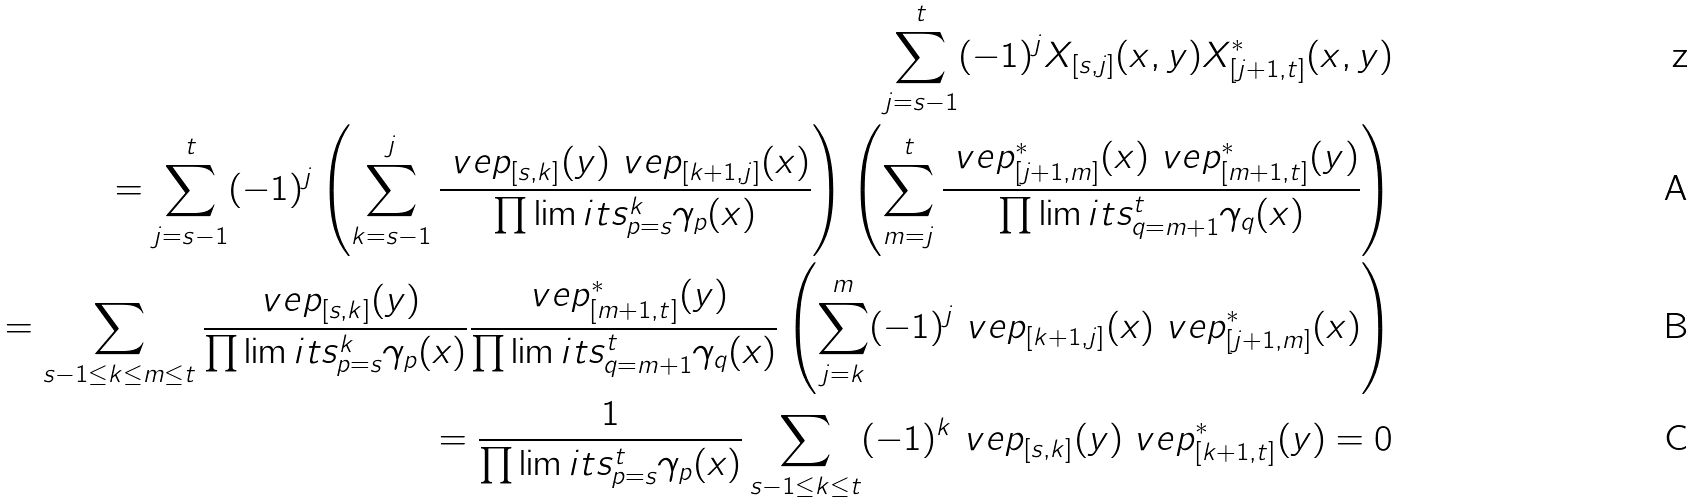Convert formula to latex. <formula><loc_0><loc_0><loc_500><loc_500>\sum _ { j = s - 1 } ^ { t } ( - 1 ) ^ { j } X _ { [ s , j ] } ( x , y ) X ^ { * } _ { [ j + 1 , t ] } ( x , y ) \\ = \sum _ { j = s - 1 } ^ { t } ( - 1 ) ^ { j } \left ( \sum _ { k = s - 1 } ^ { j } \frac { \ v e p _ { [ s , k ] } ( y ) \ v e p _ { [ k + 1 , j ] } ( x ) } { \prod \lim i t s _ { p = s } ^ { k } \gamma _ { p } ( x ) } \right ) \left ( \sum _ { m = j } ^ { t } \frac { \ v e p ^ { * } _ { [ j + 1 , m ] } ( x ) \ v e p ^ { * } _ { [ m + 1 , t ] } ( y ) } { \prod \lim i t s _ { q = m + 1 } ^ { t } \gamma _ { q } ( x ) } \right ) \\ = \sum _ { s - 1 \leq k \leq m \leq t } \frac { \ v e p _ { [ s , k ] } ( y ) } { \prod \lim i t s _ { p = s } ^ { k } \gamma _ { p } ( x ) } \frac { \ v e p ^ { * } _ { [ m + 1 , t ] } ( y ) } { \prod \lim i t s _ { q = m + 1 } ^ { t } \gamma _ { q } ( x ) } \left ( \sum _ { j = k } ^ { m } ( - 1 ) ^ { j } \ v e p _ { [ k + 1 , j ] } ( x ) \ v e p ^ { * } _ { [ j + 1 , m ] } ( x ) \right ) \\ = \frac { 1 } { { \prod \lim i t s _ { p = s } ^ { t } \gamma _ { p } ( x ) } } \sum _ { s - 1 \leq k \leq t } ( - 1 ) ^ { k } \ v e p _ { [ s , k ] } ( y ) \ v e p ^ { * } _ { [ k + 1 , t ] } ( y ) = 0</formula> 